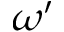<formula> <loc_0><loc_0><loc_500><loc_500>\omega ^ { \prime }</formula> 